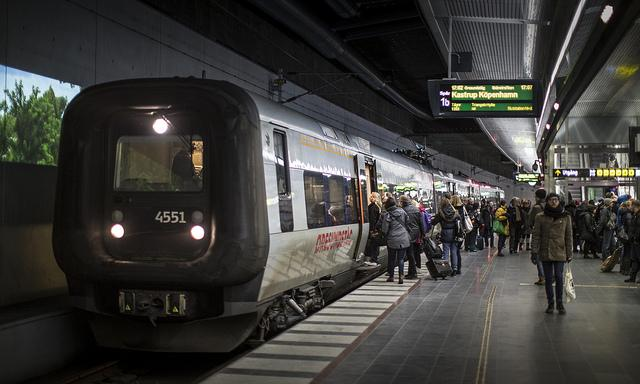What can be seen to the left of the train?

Choices:
A) ocean
B) roads
C) trees
D) mountains trees 